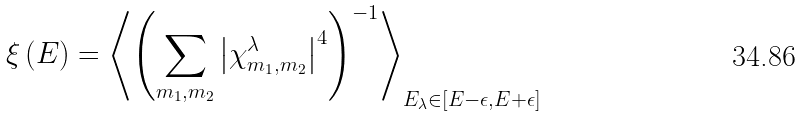<formula> <loc_0><loc_0><loc_500><loc_500>\xi \left ( E \right ) = \left \langle \left ( \sum _ { m _ { 1 } , m _ { 2 } } \left | \chi ^ { \lambda } _ { m _ { 1 } , m _ { 2 } } \right | ^ { 4 } \right ) ^ { - 1 } \right \rangle _ { E _ { \lambda } \in \left [ E - \epsilon , E + \epsilon \right ] }</formula> 